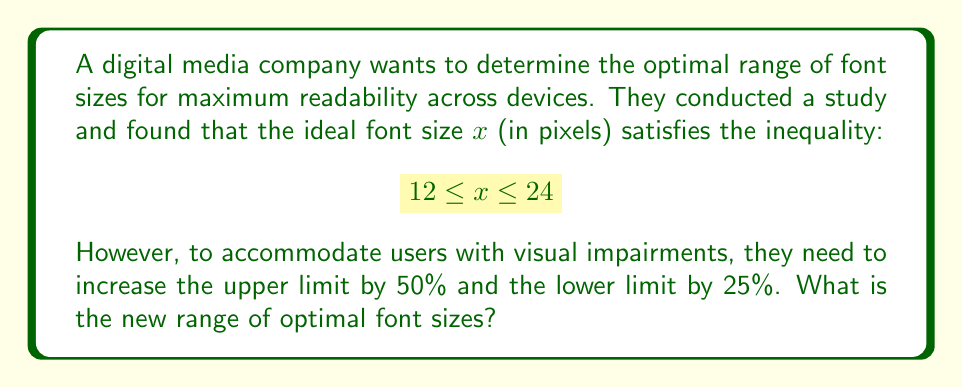Can you answer this question? 1. Let's start with the original inequality: $12 \leq x \leq 24$

2. To increase the lower limit by 25%:
   $12 * 1.25 = 15$

3. To increase the upper limit by 50%:
   $24 * 1.5 = 36$

4. The new inequality becomes:
   $15 \leq x \leq 36$

5. This represents the new range of optimal font sizes in pixels.

6. To express this as a range, we write: $[15, 36]$
Answer: $[15, 36]$ 